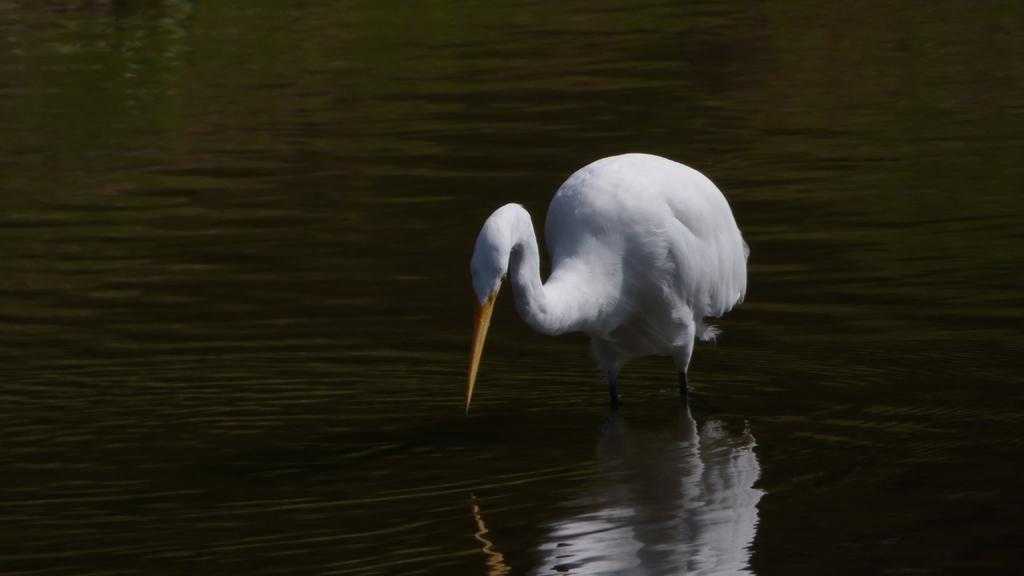Describe this image in one or two sentences. As we can see in the image there is white color bird and water. 